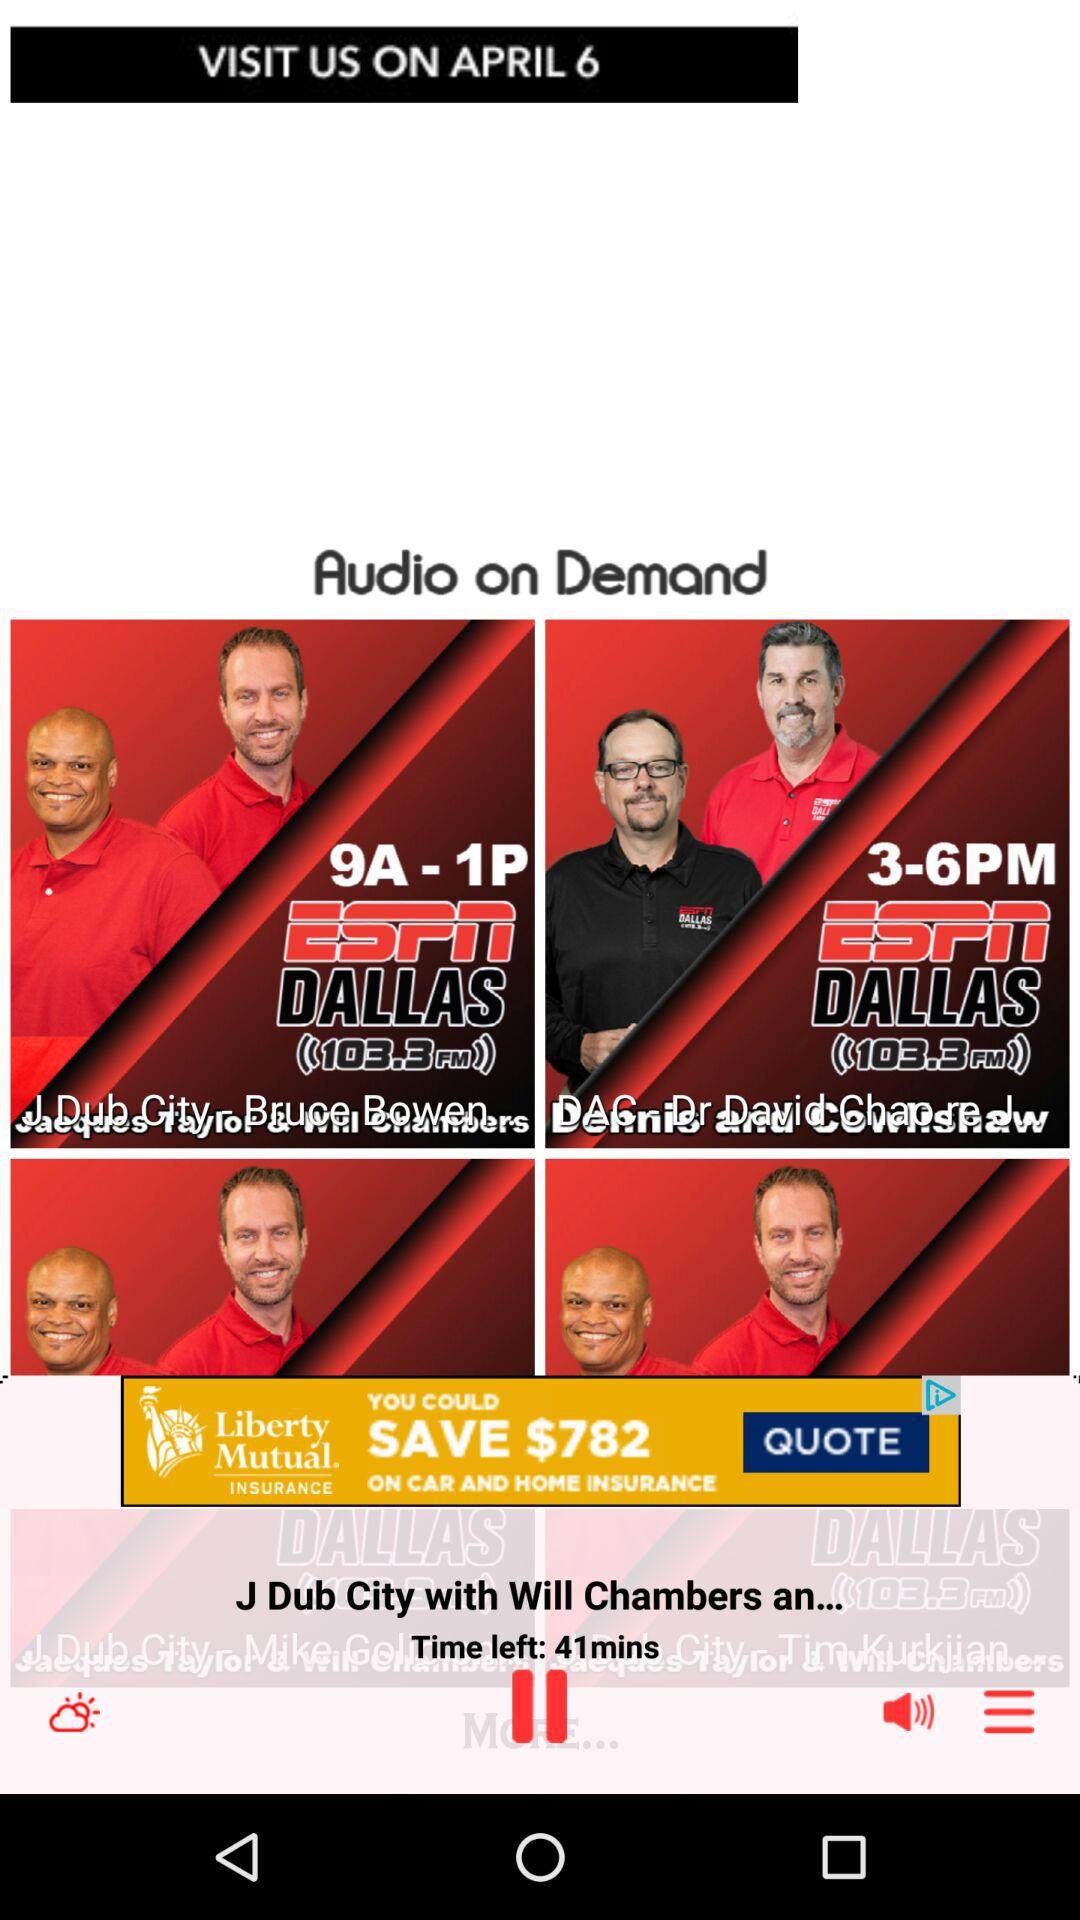How much time is left for the currently playing audio? The time left for the currently playing audio is 41 minutes. 